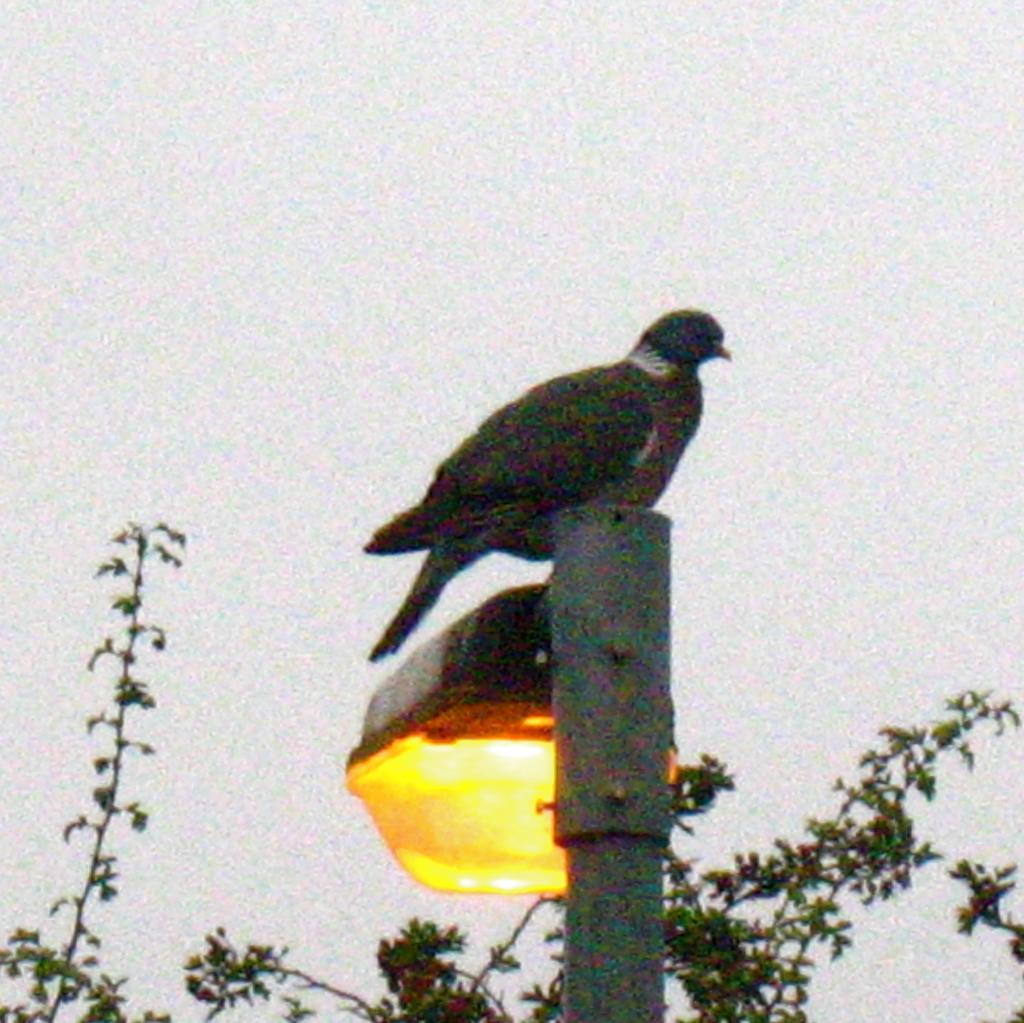What is attached to the metal pole in the image? There is a light attached to the metal pole in the image. What can be seen on the metal pole? There is a bird on the pole. Can you describe the bird's appearance? The bird is black and white in color. What is visible in the background of the image? There are trees and the sky visible in the background of the image. What type of quilt is being used to cover the bird in the image? There is no quilt present in the image, and the bird is not covered. What emotion does the bird display towards the light in the image? The image does not convey any emotions of the bird, and there is no indication of the bird's feelings towards the light. 